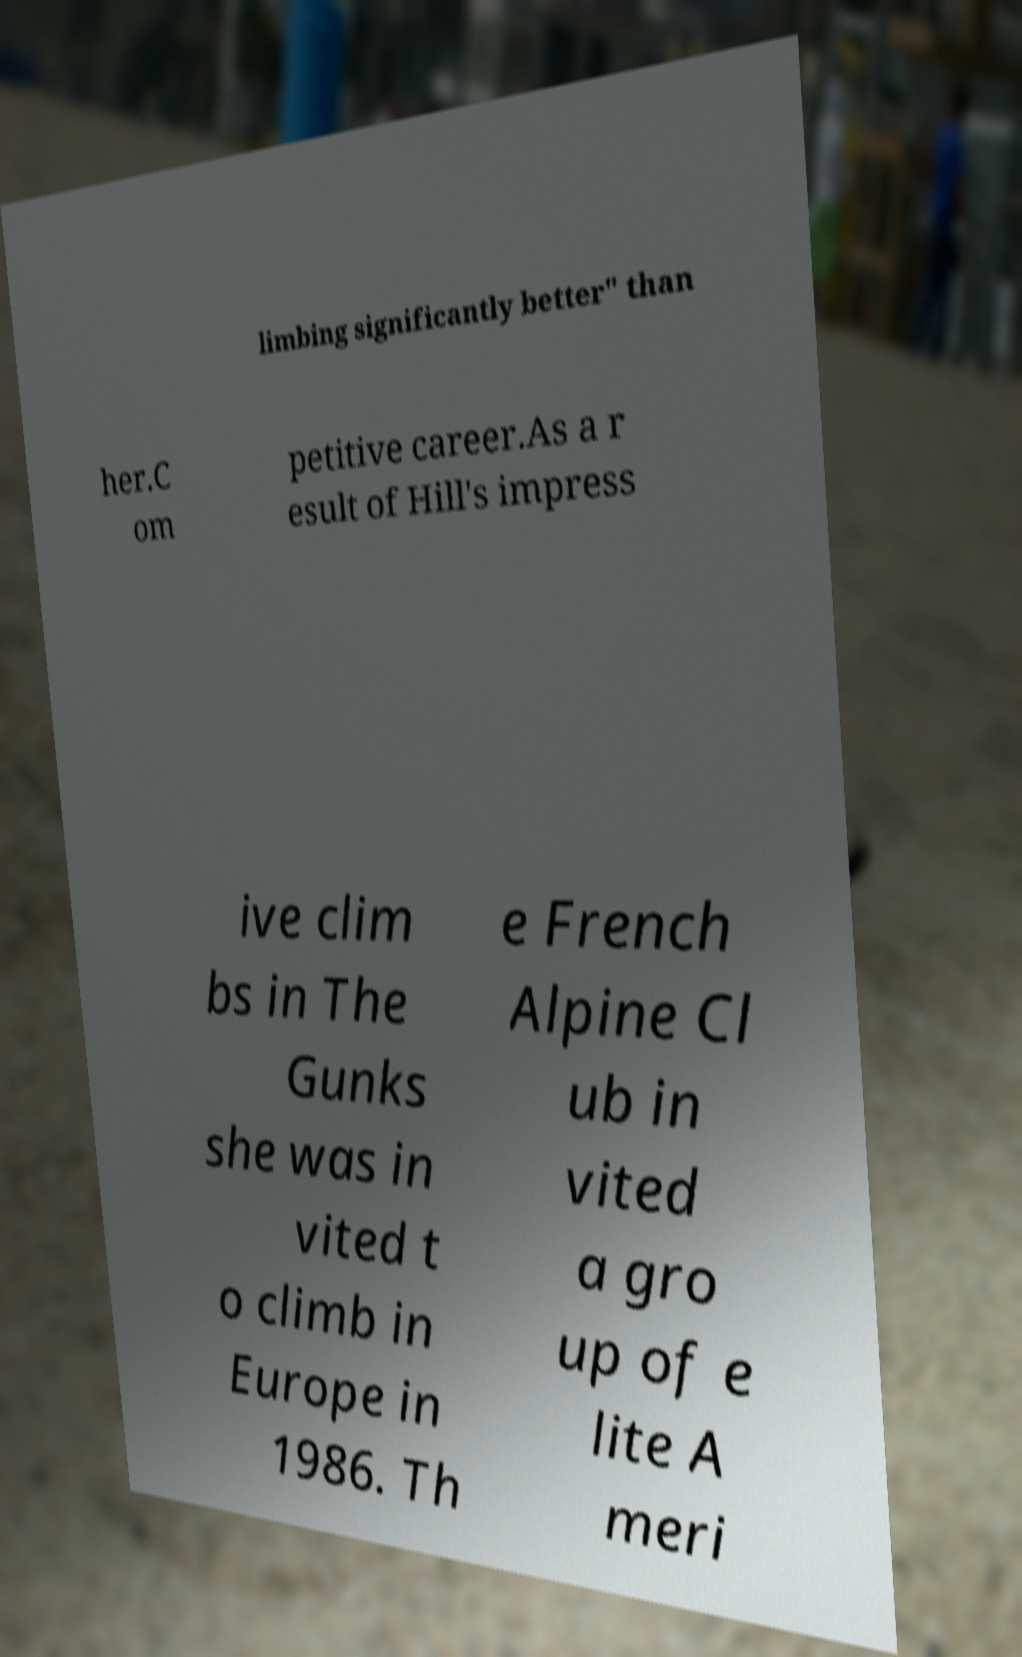Please read and relay the text visible in this image. What does it say? limbing significantly better" than her.C om petitive career.As a r esult of Hill's impress ive clim bs in The Gunks she was in vited t o climb in Europe in 1986. Th e French Alpine Cl ub in vited a gro up of e lite A meri 